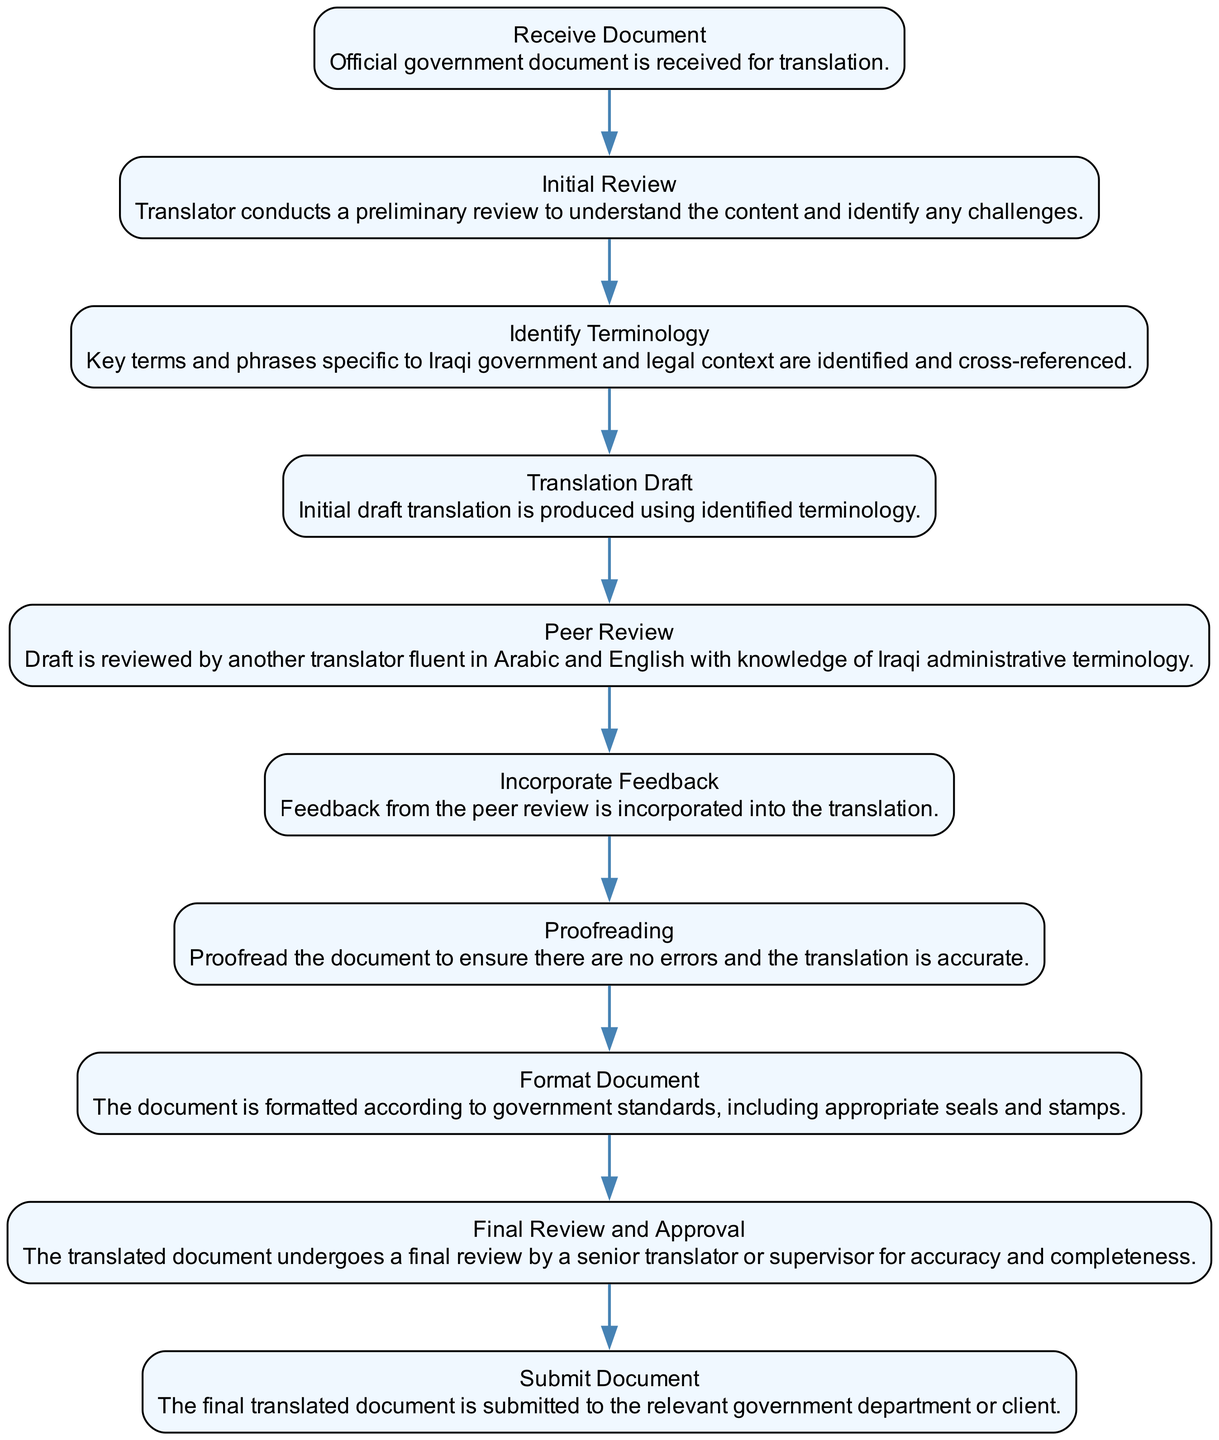What is the first step in the translation process? The first step, as indicated in the diagram, is "Receive Document." This represents the initiation of the translation workflow where an official government document is received for translation.
Answer: Receive Document How many steps are there in the translation process? By counting each unique process element listed in the diagram, there are ten steps involved in the translation process. Each step represents a distinct phase in the workflow from receiving the document to submitting it.
Answer: 10 What is the last step before the document is submitted? The last step prior to submission is "Final Review and Approval." This step ensures that the translated document is thoroughly checked for accuracy before it is sent to the appropriate authority.
Answer: Final Review and Approval Which step involves input from another translator? The "Peer Review" step involves the input from another translator. This is a critical phase where the initial draft translation is evaluated by someone else who is fluent in the relevant languages and familiar with Iraqi terminology.
Answer: Peer Review What action follows the incorporation of feedback? Following the "Incorporate Feedback" step, the next action is "Proofreading." This step aims to ensure that the document is error-free and that the translation is accurate, validating the quality of the translation.
Answer: Proofreading Which step directly follows the "Translation Draft"? The step that directly follows "Translation Draft" is "Peer Review." In this sequence, after producing an initial draft using identified terminology, it is essential for another translator to review it.
Answer: Peer Review What is the primary purpose of the "Format Document" step? The primary purpose of the "Format Document" step is to ensure that the document complies with government formatting standards, including the inclusion of appropriate seals and stamps to validate the authenticity of the document.
Answer: Format Document Name the step where errors are eliminated. The step where errors are eliminated is "Proofreading." It is specifically designed to identify and rectify any potential mistakes in the translation to ensure its accuracy before finalization.
Answer: Proofreading 